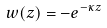Convert formula to latex. <formula><loc_0><loc_0><loc_500><loc_500>w ( z ) = - e ^ { - \kappa z }</formula> 